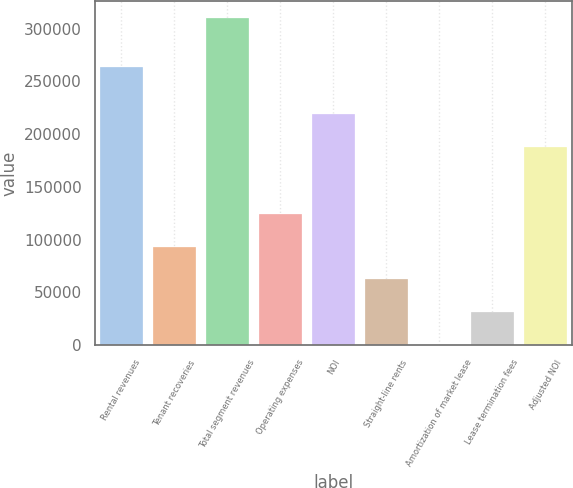<chart> <loc_0><loc_0><loc_500><loc_500><bar_chart><fcel>Rental revenues<fcel>Tenant recoveries<fcel>Total segment revenues<fcel>Operating expenses<fcel>NOI<fcel>Straight-line rents<fcel>Amortization of market lease<fcel>Lease termination fees<fcel>Adjusted NOI<nl><fcel>263726<fcel>93305.3<fcel>310341<fcel>124310<fcel>219040<fcel>62300.2<fcel>290<fcel>31295.1<fcel>188035<nl></chart> 